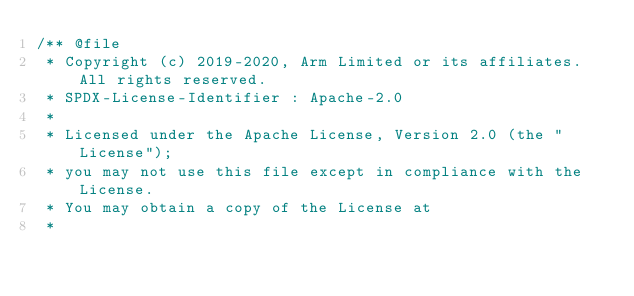Convert code to text. <code><loc_0><loc_0><loc_500><loc_500><_C_>/** @file
 * Copyright (c) 2019-2020, Arm Limited or its affiliates. All rights reserved.
 * SPDX-License-Identifier : Apache-2.0
 *
 * Licensed under the Apache License, Version 2.0 (the "License");
 * you may not use this file except in compliance with the License.
 * You may obtain a copy of the License at
 *</code> 